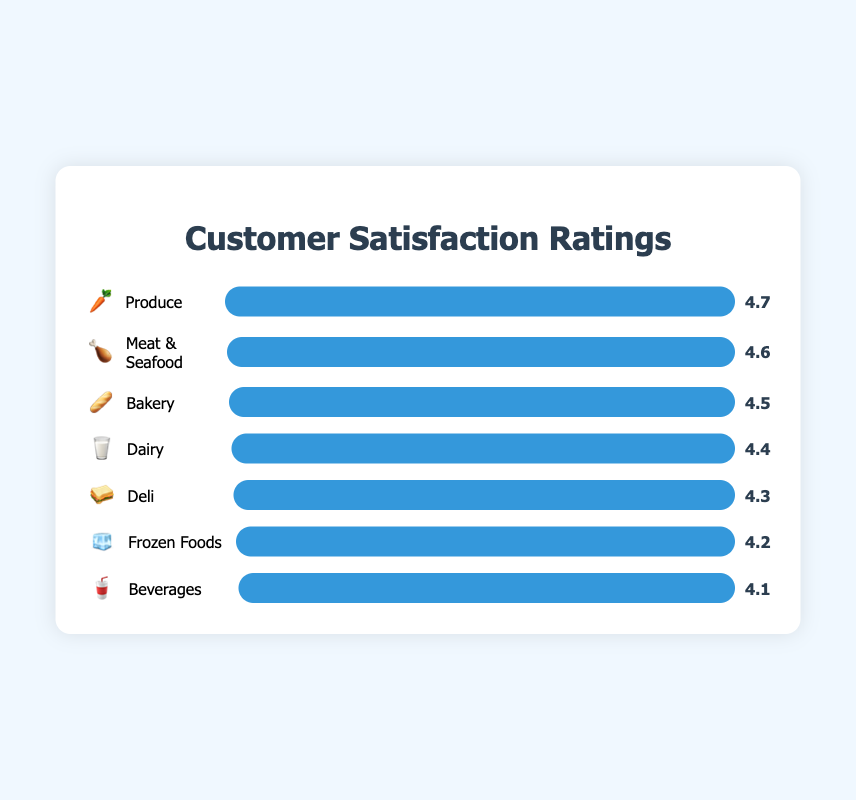What's the highest customer satisfaction rating? The highest satisfaction rating can be found by looking for the department with the longest bar and the highest value. The Produce department has the longest bar and a satisfaction rating of 4.7.
Answer: 4.7 Which department does the emoji 🥖 represent? The emoji 🥖 corresponds to the Bakery department as visually represented by the emoji next to the department name.
Answer: Bakery How does the satisfaction rating for the Meat & Seafood department 🍗 compare to the Dairy department 🥛? The Meat & Seafood department has a satisfaction rating of 4.6, while the Dairy department has a rating of 4.4. So, Meat & Seafood has a higher satisfaction rating.
Answer: Meat & Seafood has a higher rating What's the average satisfaction rating across all departments? Sum all satisfaction ratings: 4.7 (Produce) + 4.5 (Bakery) + 4.3 (Deli) + 4.6 (Meat & Seafood) + 4.4 (Dairy) + 4.2 (Frozen Foods) + 4.1 (Beverages) = 30.8. Then, divide by the number of departments, which is 7. So, 30.8 / 7 ≈ 4.4.
Answer: 4.4 Which department has the lowest satisfaction rating, and what is it? The department with the shortest bar and the lowest number is the Beverages department. Its satisfaction rating is 4.1.
Answer: Beverages, 4.1 By how much does the satisfaction rating for Produce 🥕 exceed that for Beverages 🥤? Produce has a satisfaction rating of 4.7, and Beverages has a rating of 4.1. Subtracting these gives 4.7 - 4.1 = 0.6.
Answer: 0.6 What is the combined satisfaction rating for Frozen Foods 🧊 and Deli 🥪 departments? The satisfaction rating for Frozen Foods is 4.2, and for Deli, it is 4.3. Adding them together gives 4.2 + 4.3 = 8.5.
Answer: 8.5 Which departments have a satisfaction rating above 4.5? The departments with satisfaction ratings above 4.5 are Produce (4.7) and Meat & Seafood (4.6).
Answer: Produce, Meat & Seafood What's the second-highest customer satisfaction rating and which department does it correspond to? The second-highest rating can be identified by finding the rating just below the highest. Meat & Seafood has the second-highest rating of 4.6, just below Produce (4.7).
Answer: 4.6, Meat & Seafood 